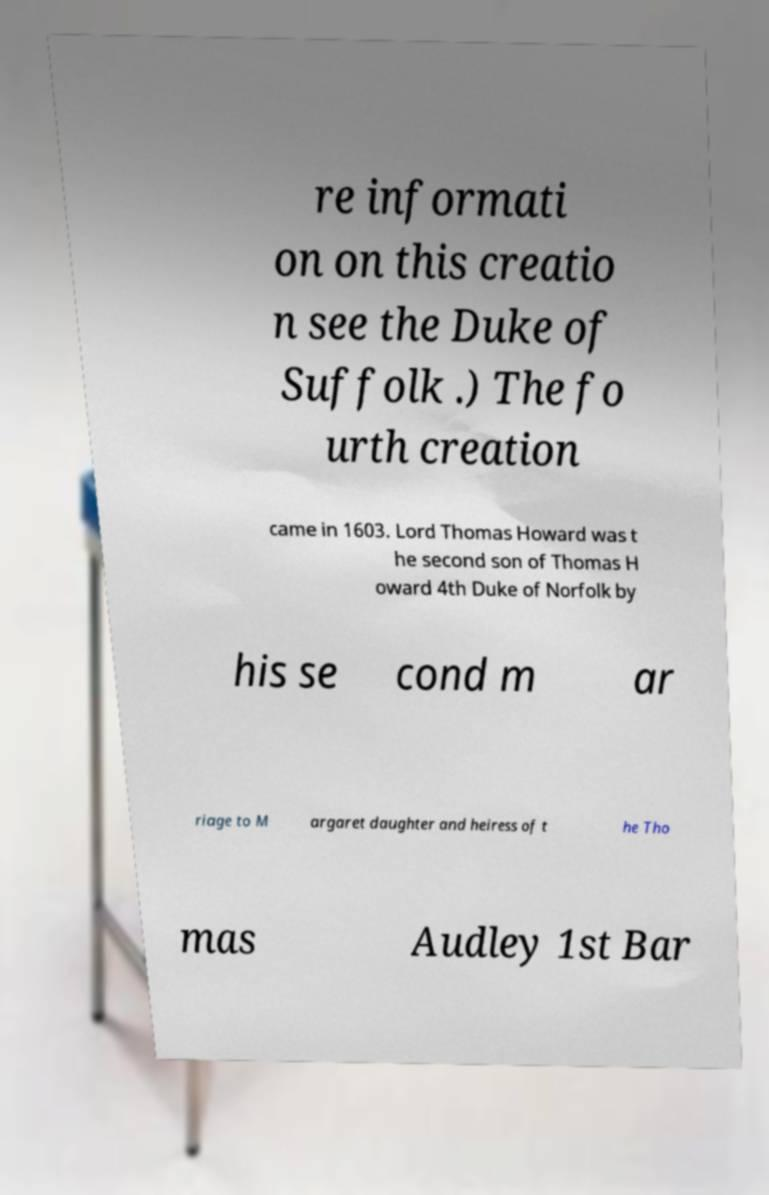Please identify and transcribe the text found in this image. re informati on on this creatio n see the Duke of Suffolk .) The fo urth creation came in 1603. Lord Thomas Howard was t he second son of Thomas H oward 4th Duke of Norfolk by his se cond m ar riage to M argaret daughter and heiress of t he Tho mas Audley 1st Bar 